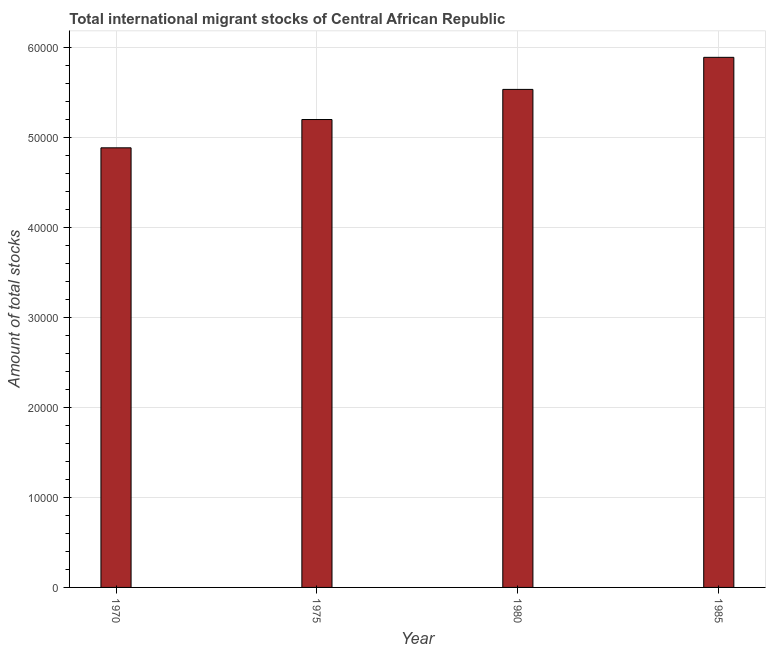Does the graph contain any zero values?
Your answer should be compact. No. What is the title of the graph?
Your answer should be compact. Total international migrant stocks of Central African Republic. What is the label or title of the X-axis?
Make the answer very short. Year. What is the label or title of the Y-axis?
Make the answer very short. Amount of total stocks. What is the total number of international migrant stock in 1970?
Provide a succinct answer. 4.89e+04. Across all years, what is the maximum total number of international migrant stock?
Keep it short and to the point. 5.89e+04. Across all years, what is the minimum total number of international migrant stock?
Provide a succinct answer. 4.89e+04. In which year was the total number of international migrant stock minimum?
Your response must be concise. 1970. What is the sum of the total number of international migrant stock?
Your answer should be compact. 2.15e+05. What is the difference between the total number of international migrant stock in 1970 and 1980?
Ensure brevity in your answer.  -6494. What is the average total number of international migrant stock per year?
Your answer should be very brief. 5.38e+04. What is the median total number of international migrant stock?
Your answer should be very brief. 5.37e+04. Do a majority of the years between 1975 and 1985 (inclusive) have total number of international migrant stock greater than 26000 ?
Make the answer very short. Yes. What is the ratio of the total number of international migrant stock in 1980 to that in 1985?
Provide a short and direct response. 0.94. Is the total number of international migrant stock in 1970 less than that in 1980?
Provide a succinct answer. Yes. Is the difference between the total number of international migrant stock in 1975 and 1985 greater than the difference between any two years?
Make the answer very short. No. What is the difference between the highest and the second highest total number of international migrant stock?
Offer a very short reply. 3564. What is the difference between the highest and the lowest total number of international migrant stock?
Give a very brief answer. 1.01e+04. In how many years, is the total number of international migrant stock greater than the average total number of international migrant stock taken over all years?
Offer a terse response. 2. What is the difference between two consecutive major ticks on the Y-axis?
Your answer should be very brief. 10000. What is the Amount of total stocks in 1970?
Provide a succinct answer. 4.89e+04. What is the Amount of total stocks of 1975?
Provide a succinct answer. 5.20e+04. What is the Amount of total stocks of 1980?
Your answer should be very brief. 5.54e+04. What is the Amount of total stocks of 1985?
Make the answer very short. 5.89e+04. What is the difference between the Amount of total stocks in 1970 and 1975?
Give a very brief answer. -3146. What is the difference between the Amount of total stocks in 1970 and 1980?
Offer a terse response. -6494. What is the difference between the Amount of total stocks in 1970 and 1985?
Your answer should be compact. -1.01e+04. What is the difference between the Amount of total stocks in 1975 and 1980?
Offer a very short reply. -3348. What is the difference between the Amount of total stocks in 1975 and 1985?
Keep it short and to the point. -6912. What is the difference between the Amount of total stocks in 1980 and 1985?
Provide a short and direct response. -3564. What is the ratio of the Amount of total stocks in 1970 to that in 1980?
Ensure brevity in your answer.  0.88. What is the ratio of the Amount of total stocks in 1970 to that in 1985?
Ensure brevity in your answer.  0.83. What is the ratio of the Amount of total stocks in 1975 to that in 1980?
Your answer should be very brief. 0.94. What is the ratio of the Amount of total stocks in 1975 to that in 1985?
Make the answer very short. 0.88. 